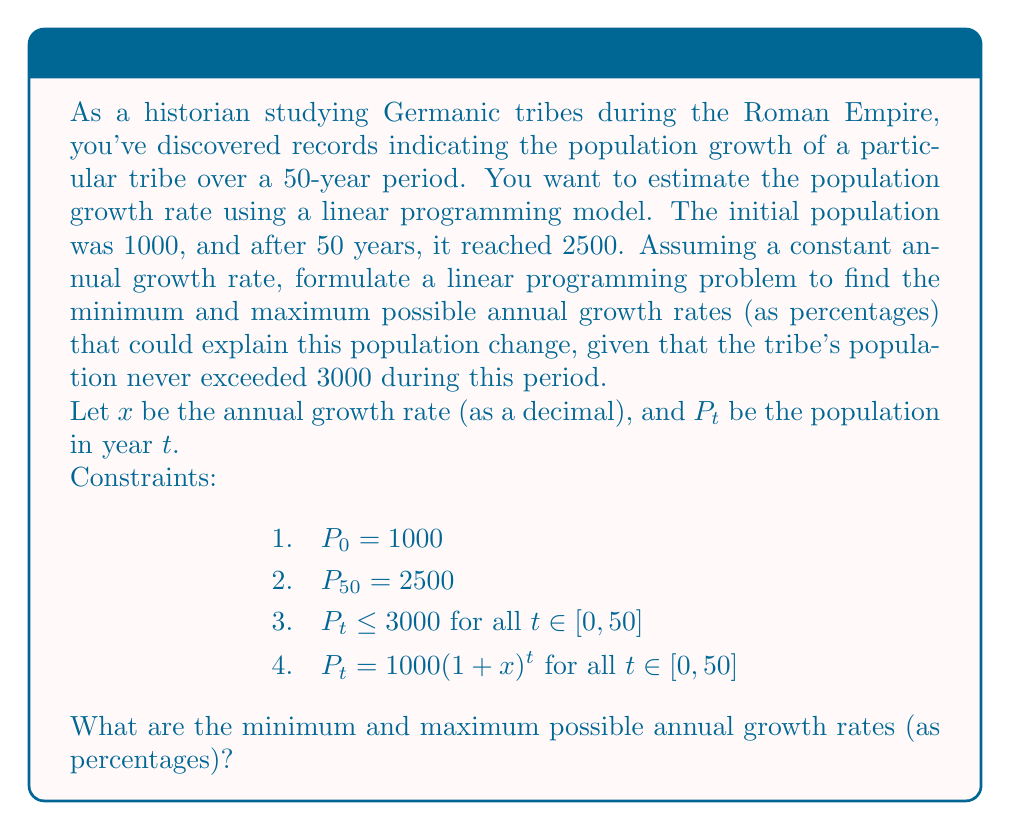What is the answer to this math problem? To solve this problem, we'll follow these steps:

1) First, we need to linearize the exponential growth equation:
   $P_t = 1000(1+x)^t$
   Taking logarithms of both sides:
   $\ln(P_t) = \ln(1000) + t\ln(1+x)$

2) For small values of $x$, we can approximate $\ln(1+x) \approx x$. This gives us:
   $\ln(P_t) \approx \ln(1000) + tx$

3) Now we can set up our linear constraints:
   a) $\ln(2500) \approx \ln(1000) + 50x$ (final population)
   b) $\ln(3000) \geq \ln(1000) + tx$ for all $t \in [0, 50]$ (maximum population)

4) Solving (a):
   $\ln(2.5) \approx 50x$
   $x \approx \frac{\ln(2.5)}{50} \approx 0.0183$ or 1.83% per year

5) For (b), the most restrictive case is when $t = 50$:
   $\ln(3) \geq 50x$
   $x \leq \frac{\ln(3)}{50} \approx 0.0220$ or 2.20% per year

6) Therefore, the annual growth rate must be between 1.83% and 2.20%.

To find the exact minimum and maximum, we would need to solve the non-linear problem, but this linear approximation gives us a good estimate.
Answer: Minimum ≈ 1.83%, Maximum ≈ 2.20% 